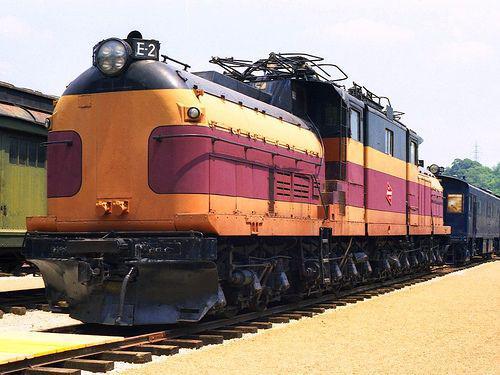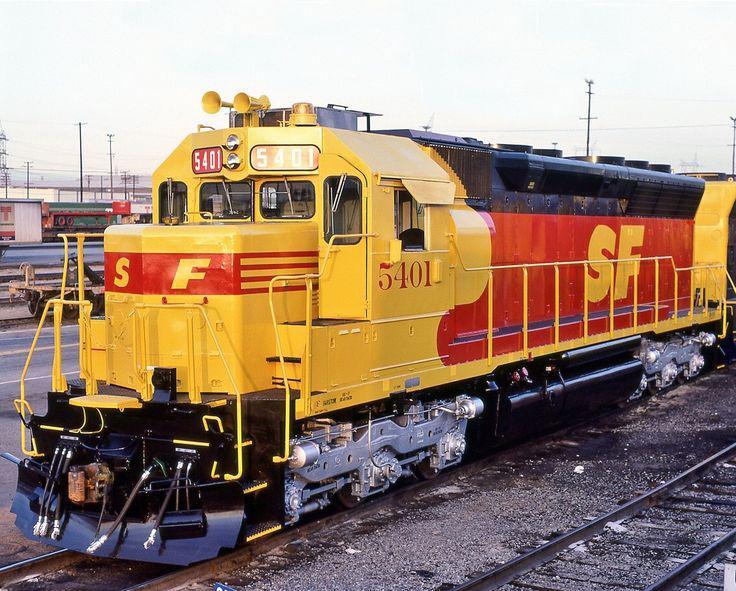The first image is the image on the left, the second image is the image on the right. Examine the images to the left and right. Is the description "The train in the right image is facing left." accurate? Answer yes or no. Yes. The first image is the image on the left, the second image is the image on the right. Given the left and right images, does the statement "In one image there is a yellow and orange train sitting on rails in the center of the image." hold true? Answer yes or no. Yes. 